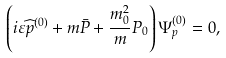Convert formula to latex. <formula><loc_0><loc_0><loc_500><loc_500>\left ( i \varepsilon \widehat { p } ^ { ( 0 ) } + m \bar { P } + \frac { m _ { 0 } ^ { 2 } } { m } P _ { 0 } \right ) \Psi ^ { ( 0 ) } _ { p } = 0 ,</formula> 